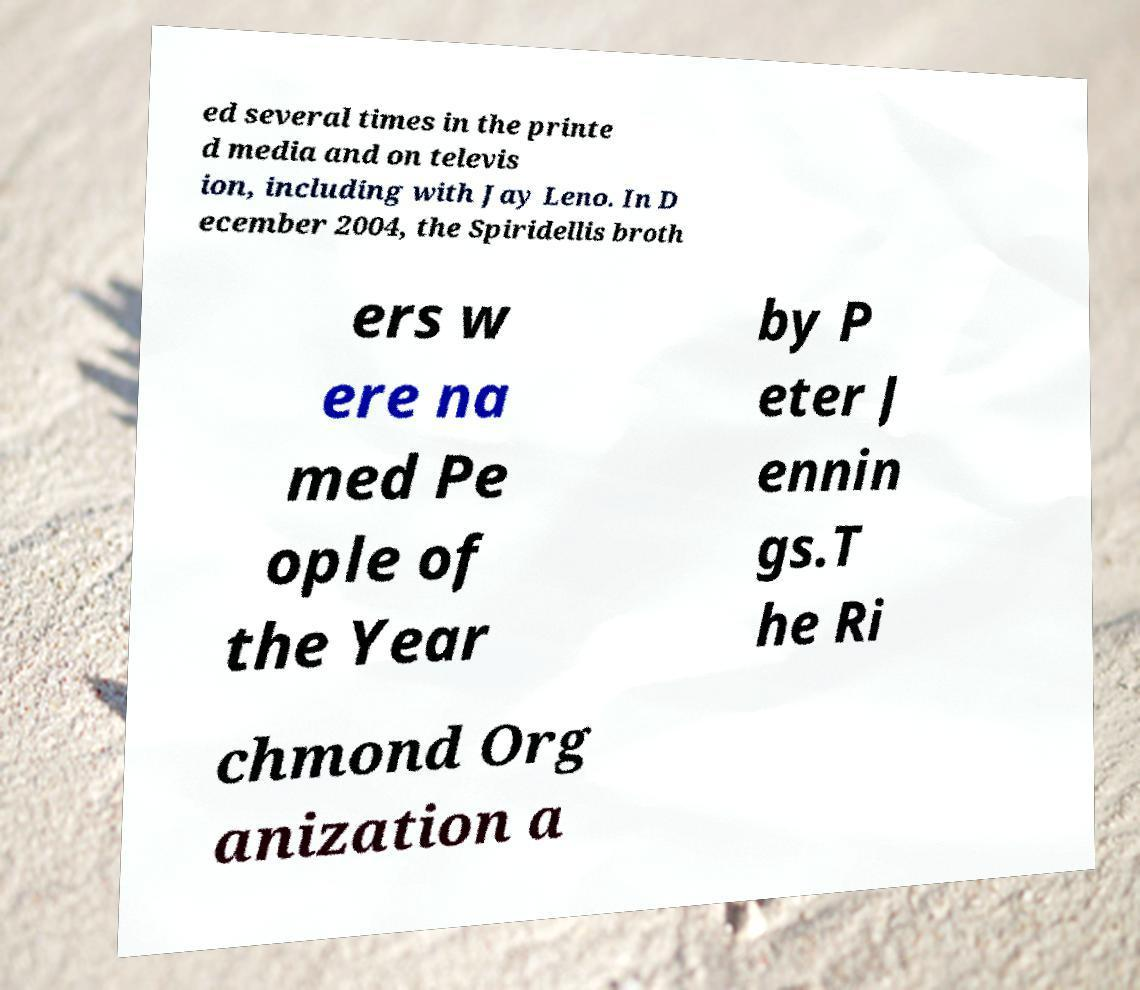Could you extract and type out the text from this image? ed several times in the printe d media and on televis ion, including with Jay Leno. In D ecember 2004, the Spiridellis broth ers w ere na med Pe ople of the Year by P eter J ennin gs.T he Ri chmond Org anization a 